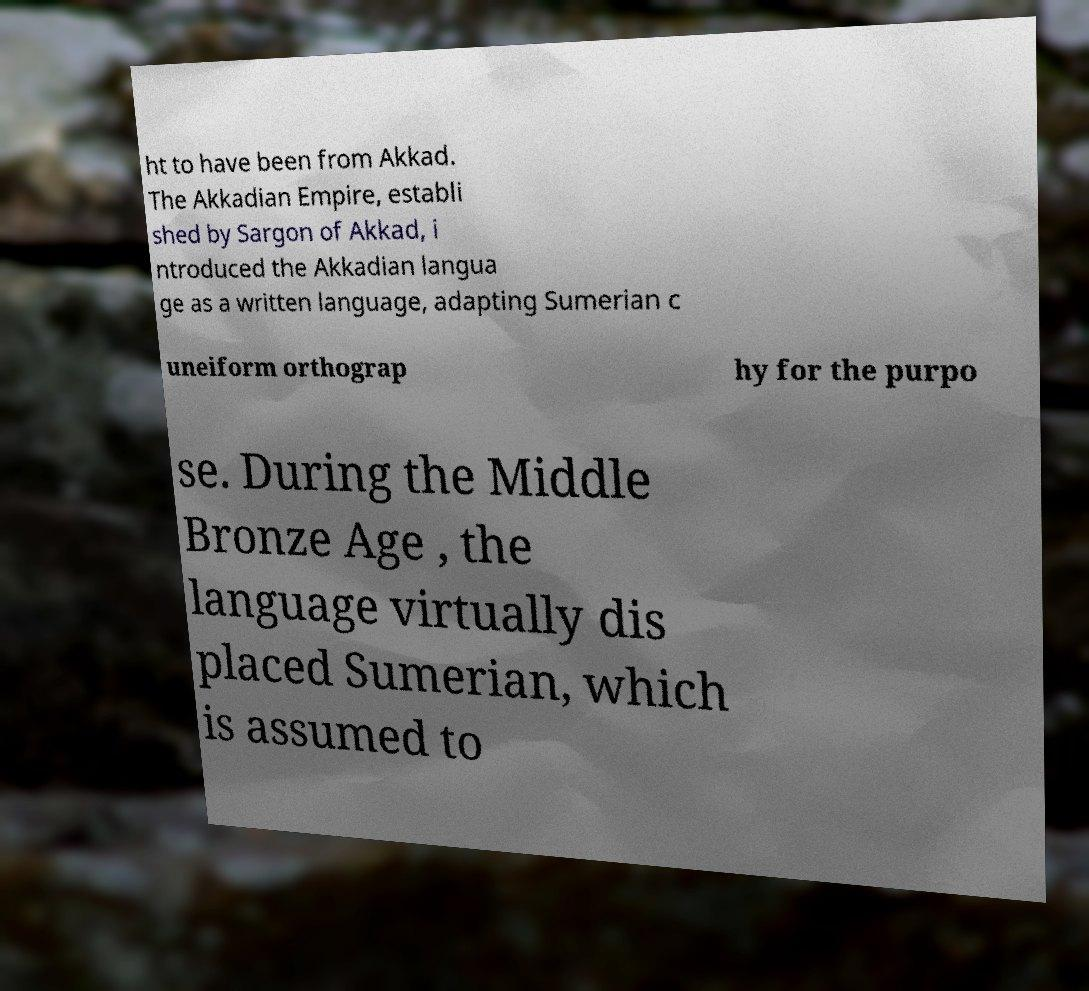There's text embedded in this image that I need extracted. Can you transcribe it verbatim? ht to have been from Akkad. The Akkadian Empire, establi shed by Sargon of Akkad, i ntroduced the Akkadian langua ge as a written language, adapting Sumerian c uneiform orthograp hy for the purpo se. During the Middle Bronze Age , the language virtually dis placed Sumerian, which is assumed to 